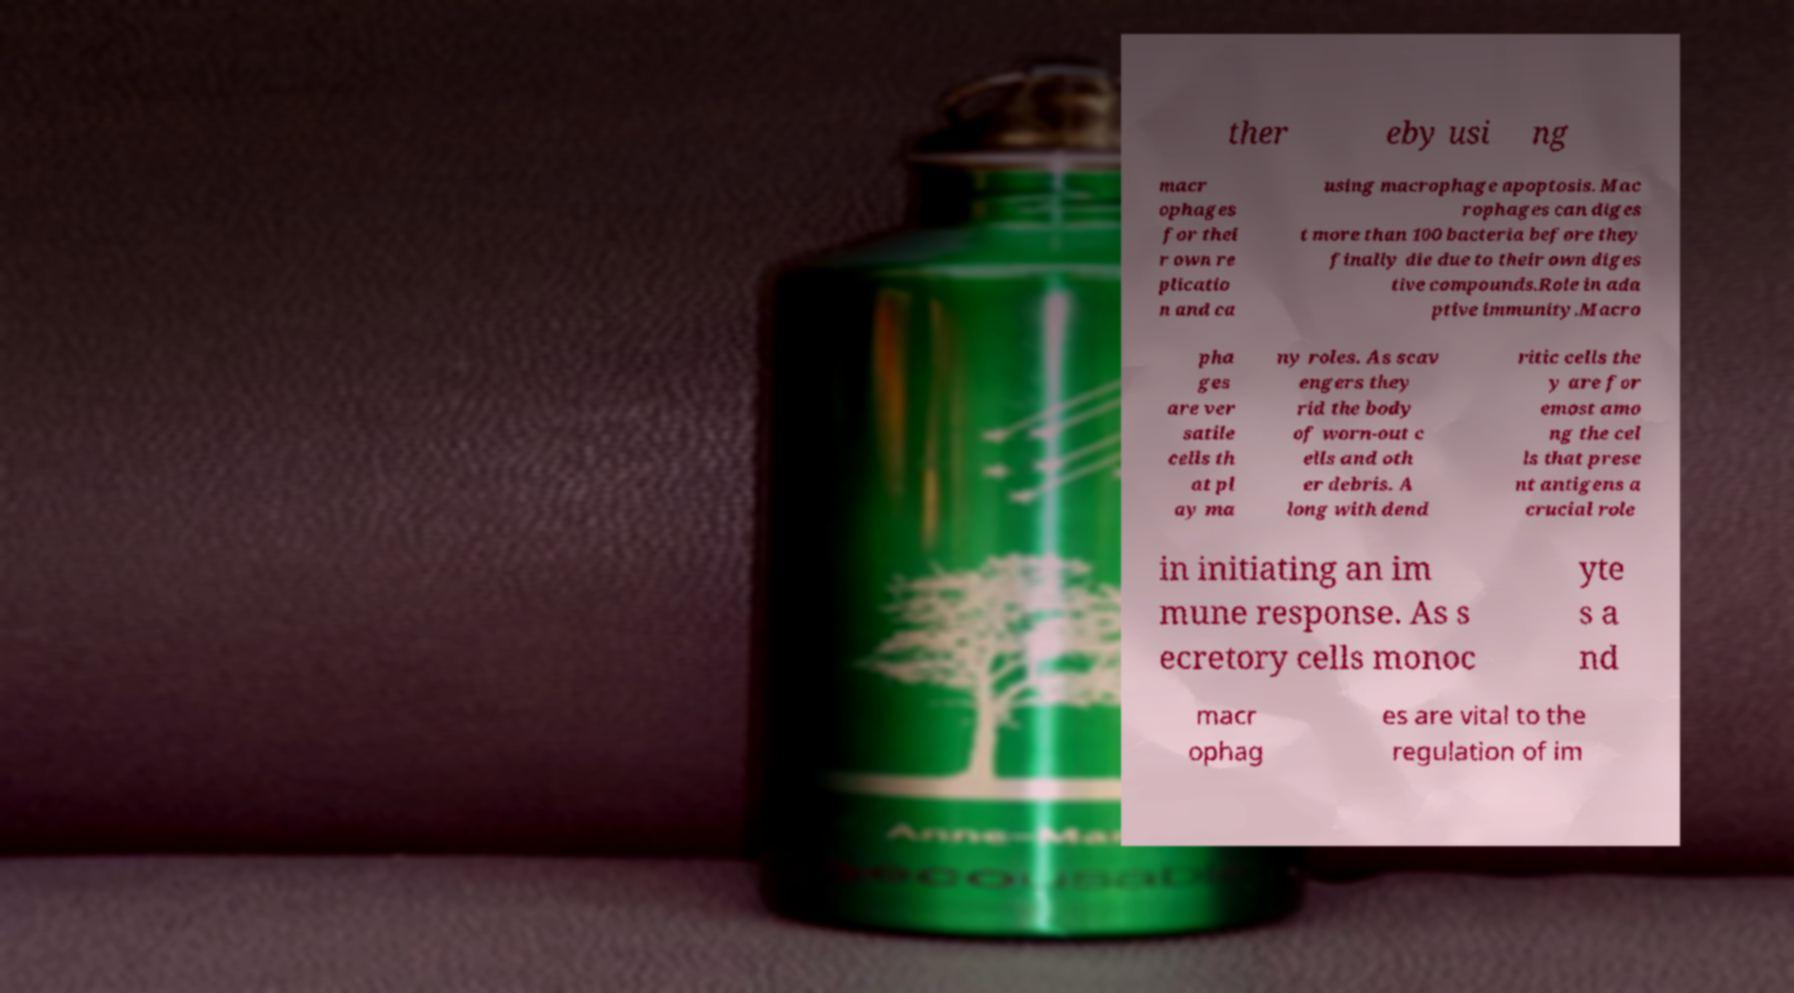Could you assist in decoding the text presented in this image and type it out clearly? ther eby usi ng macr ophages for thei r own re plicatio n and ca using macrophage apoptosis. Mac rophages can diges t more than 100 bacteria before they finally die due to their own diges tive compounds.Role in ada ptive immunity.Macro pha ges are ver satile cells th at pl ay ma ny roles. As scav engers they rid the body of worn-out c ells and oth er debris. A long with dend ritic cells the y are for emost amo ng the cel ls that prese nt antigens a crucial role in initiating an im mune response. As s ecretory cells monoc yte s a nd macr ophag es are vital to the regulation of im 